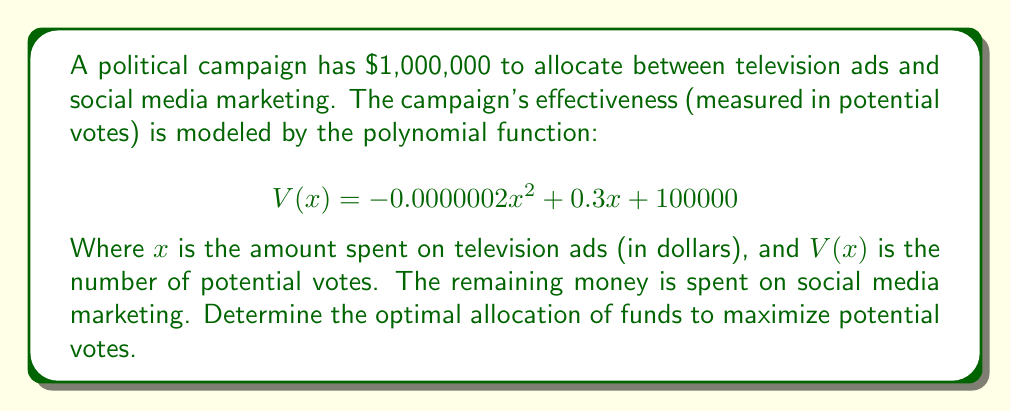Could you help me with this problem? To find the optimal allocation, we need to maximize the function $V(x)$. This is a quadratic function, so we can find its maximum using calculus:

1. Find the derivative of $V(x)$:
   $$V'(x) = -0.0000004x + 0.3$$

2. Set the derivative to zero and solve for x:
   $$-0.0000004x + 0.3 = 0$$
   $$-0.0000004x = -0.3$$
   $$x = 750000$$

3. Verify this is a maximum by checking the second derivative:
   $$V''(x) = -0.0000004 < 0$$, confirming a maximum.

4. The optimal allocation for TV ads is $750,000.

5. The remaining $250,000 should be allocated to social media marketing.

6. Calculate the maximum number of potential votes:
   $$V(750000) = -0.0000002(750000)^2 + 0.3(750000) + 100000$$
   $$= -112500 + 225000 + 100000 = 212500$$ votes

This allocation maximizes the campaign's effectiveness, potentially reaching 212,500 voters.
Answer: $750,000 for TV ads, $250,000 for social media; 212,500 potential votes 